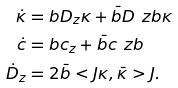<formula> <loc_0><loc_0><loc_500><loc_500>\dot { \kappa } & = b D _ { z } \kappa + \bar { b } D _ { \ } z b \kappa \\ \dot { c } & = b c _ { z } + \bar { b } c _ { \ } z b \\ \dot { D } _ { z } & = 2 \bar { b } < J \kappa , \bar { \kappa } > J .</formula> 